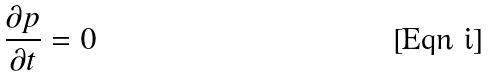Convert formula to latex. <formula><loc_0><loc_0><loc_500><loc_500>\frac { \partial p } { \partial t } = 0</formula> 